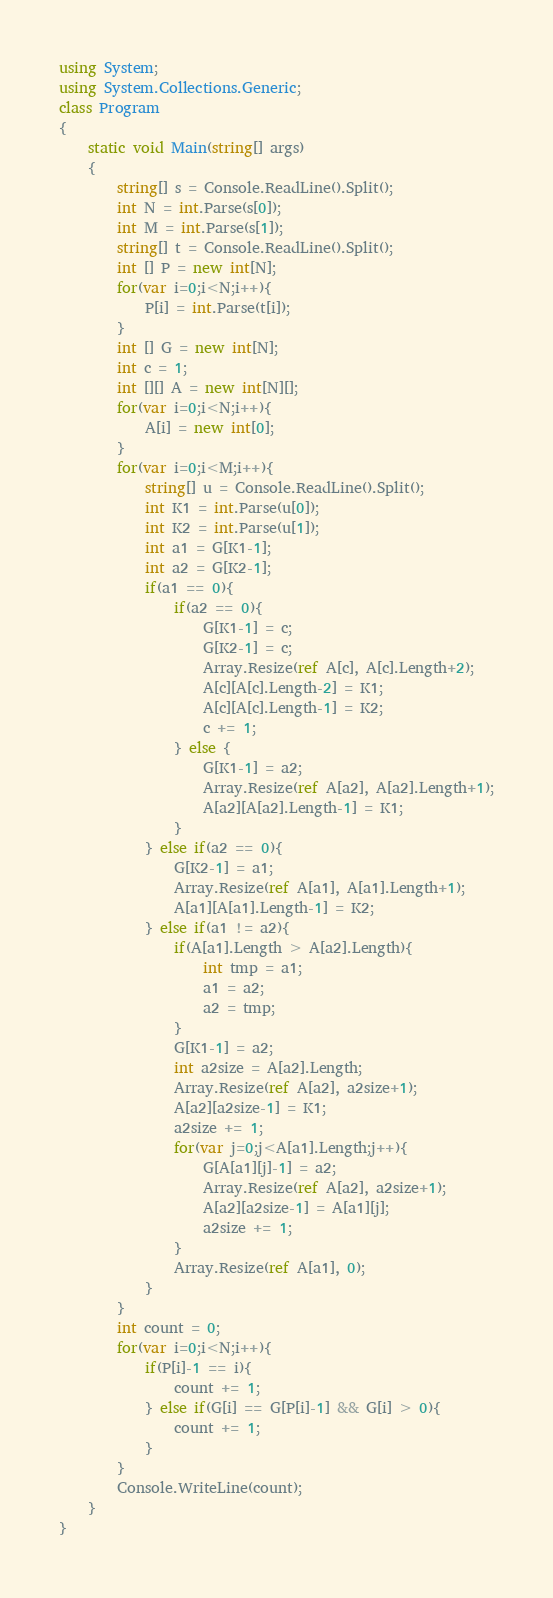Convert code to text. <code><loc_0><loc_0><loc_500><loc_500><_C#_>using System;
using System.Collections.Generic;
class Program
{
	static void Main(string[] args)
	{
		string[] s = Console.ReadLine().Split();
		int N = int.Parse(s[0]);
		int M = int.Parse(s[1]);
		string[] t = Console.ReadLine().Split();
		int [] P = new int[N];
		for(var i=0;i<N;i++){
			P[i] = int.Parse(t[i]);
		}
		int [] G = new int[N];
		int c = 1;
		int [][] A = new int[N][];
		for(var i=0;i<N;i++){
			A[i] = new int[0];
		}
		for(var i=0;i<M;i++){
			string[] u = Console.ReadLine().Split();
			int K1 = int.Parse(u[0]);
			int K2 = int.Parse(u[1]);
			int a1 = G[K1-1];
			int a2 = G[K2-1];
			if(a1 == 0){
				if(a2 == 0){
					G[K1-1] = c;
					G[K2-1] = c;
					Array.Resize(ref A[c], A[c].Length+2);
					A[c][A[c].Length-2] = K1;
					A[c][A[c].Length-1] = K2;
					c += 1;
				} else {
					G[K1-1] = a2;
					Array.Resize(ref A[a2], A[a2].Length+1);
					A[a2][A[a2].Length-1] = K1;
				}
			} else if(a2 == 0){
				G[K2-1] = a1;
				Array.Resize(ref A[a1], A[a1].Length+1);
				A[a1][A[a1].Length-1] = K2;
			} else if(a1 != a2){
				if(A[a1].Length > A[a2].Length){ 
					int tmp = a1;
					a1 = a2;
					a2 = tmp;
				}
				G[K1-1] = a2;
				int a2size = A[a2].Length;
				Array.Resize(ref A[a2], a2size+1);
				A[a2][a2size-1] = K1;
				a2size += 1;
				for(var j=0;j<A[a1].Length;j++){
					G[A[a1][j]-1] = a2;
					Array.Resize(ref A[a2], a2size+1);
					A[a2][a2size-1] = A[a1][j];
					a2size += 1;
				}
				Array.Resize(ref A[a1], 0);
			}
		}
		int count = 0;
		for(var i=0;i<N;i++){
			if(P[i]-1 == i){
				count += 1;
			} else if(G[i] == G[P[i]-1] && G[i] > 0){
				count += 1;
			}
		}
		Console.WriteLine(count);
	}
}</code> 